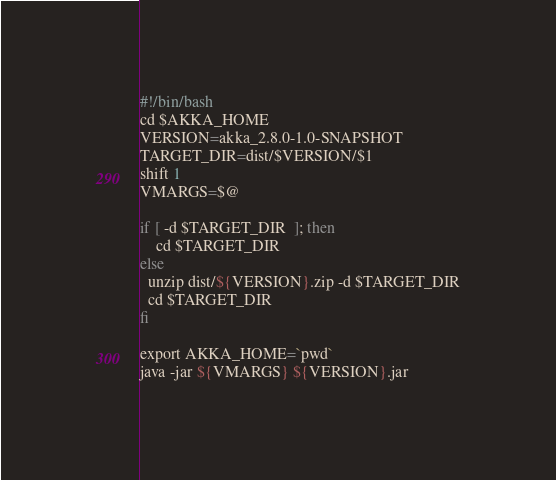<code> <loc_0><loc_0><loc_500><loc_500><_Bash_>#!/bin/bash
cd $AKKA_HOME
VERSION=akka_2.8.0-1.0-SNAPSHOT
TARGET_DIR=dist/$VERSION/$1
shift 1
VMARGS=$@

if [ -d $TARGET_DIR  ]; then
    cd $TARGET_DIR
else 
  unzip dist/${VERSION}.zip -d $TARGET_DIR
  cd $TARGET_DIR
fi

export AKKA_HOME=`pwd`
java -jar ${VMARGS} ${VERSION}.jar</code> 